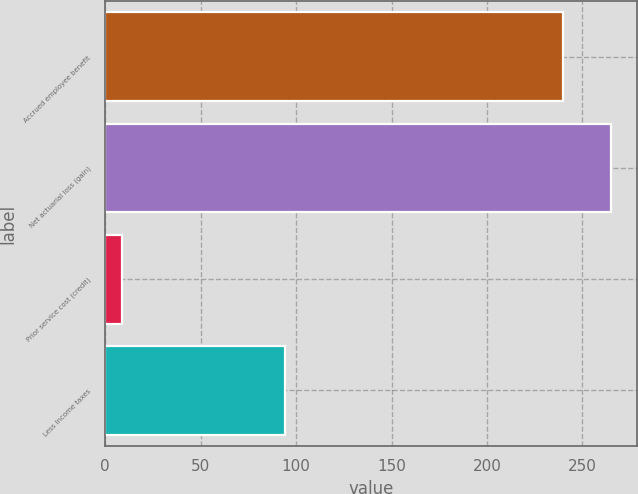Convert chart. <chart><loc_0><loc_0><loc_500><loc_500><bar_chart><fcel>Accrued employee benefit<fcel>Net actuarial loss (gain)<fcel>Prior service cost (credit)<fcel>Less Income taxes<nl><fcel>240<fcel>265.2<fcel>9<fcel>94<nl></chart> 